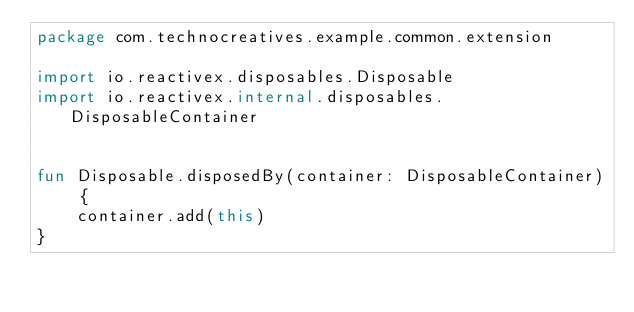Convert code to text. <code><loc_0><loc_0><loc_500><loc_500><_Kotlin_>package com.technocreatives.example.common.extension

import io.reactivex.disposables.Disposable
import io.reactivex.internal.disposables.DisposableContainer


fun Disposable.disposedBy(container: DisposableContainer) {
    container.add(this)
}</code> 